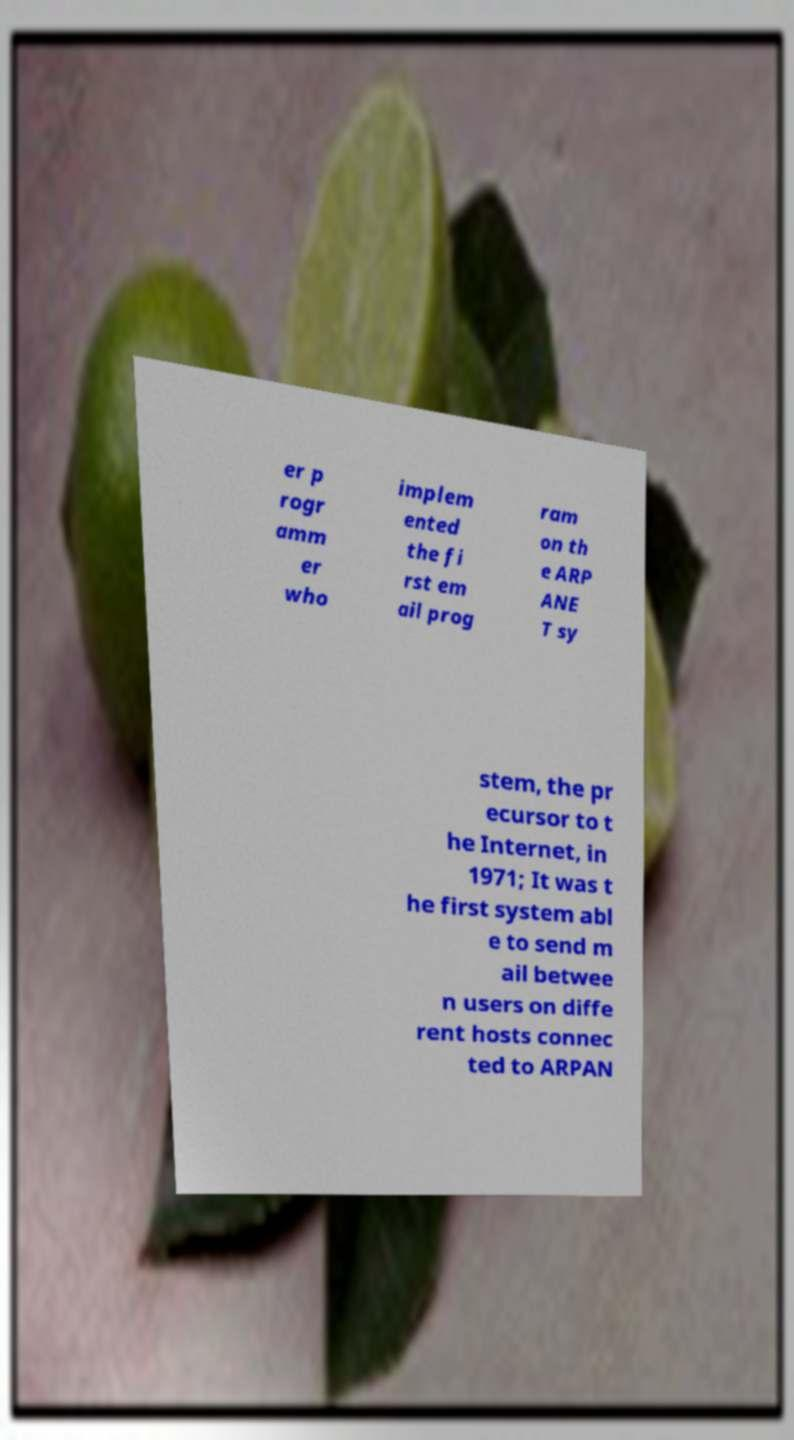Can you read and provide the text displayed in the image?This photo seems to have some interesting text. Can you extract and type it out for me? er p rogr amm er who implem ented the fi rst em ail prog ram on th e ARP ANE T sy stem, the pr ecursor to t he Internet, in 1971; It was t he first system abl e to send m ail betwee n users on diffe rent hosts connec ted to ARPAN 